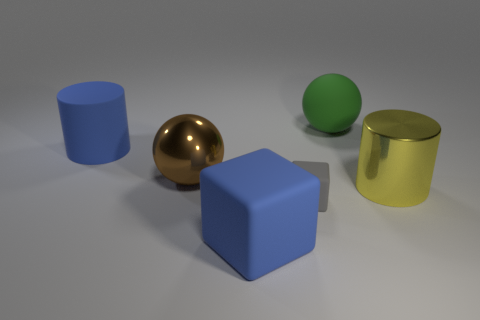Do the cylinder left of the rubber ball and the large cube have the same color?
Provide a succinct answer. Yes. There is a green thing that is made of the same material as the tiny gray cube; what shape is it?
Your answer should be very brief. Sphere. Is there a matte block of the same color as the rubber cylinder?
Ensure brevity in your answer.  Yes. What is the size of the cylinder that is on the left side of the big green matte thing?
Keep it short and to the point. Large. There is another matte thing that is the same shape as the small gray rubber object; what color is it?
Offer a very short reply. Blue. Is there anything else that is the same size as the gray matte object?
Offer a very short reply. No. What is the color of the ball that is the same material as the blue cube?
Your response must be concise. Green. There is a matte thing that is both on the right side of the blue cube and on the left side of the green thing; what size is it?
Your answer should be compact. Small. Is the number of big yellow metallic cylinders that are left of the big yellow thing less than the number of large matte things that are on the right side of the small gray matte object?
Your answer should be very brief. Yes. Do the big cylinder that is on the left side of the yellow cylinder and the cylinder in front of the big brown ball have the same material?
Provide a succinct answer. No. 